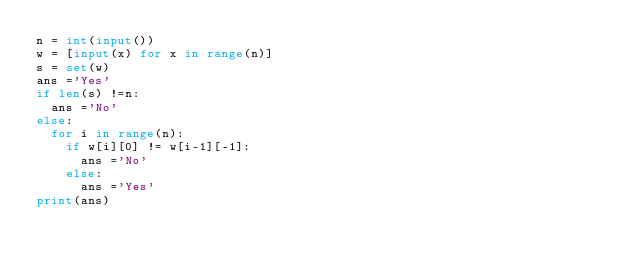Convert code to text. <code><loc_0><loc_0><loc_500><loc_500><_Python_>n = int(input())
w = [input(x) for x in range(n)]
s = set(w)
ans ='Yes'
if len(s) !=n:
  ans ='No'
else:
  for i in range(n):
    if w[i][0] != w[i-1][-1]:
      ans ='No'
    else:
      ans ='Yes'
print(ans)
</code> 